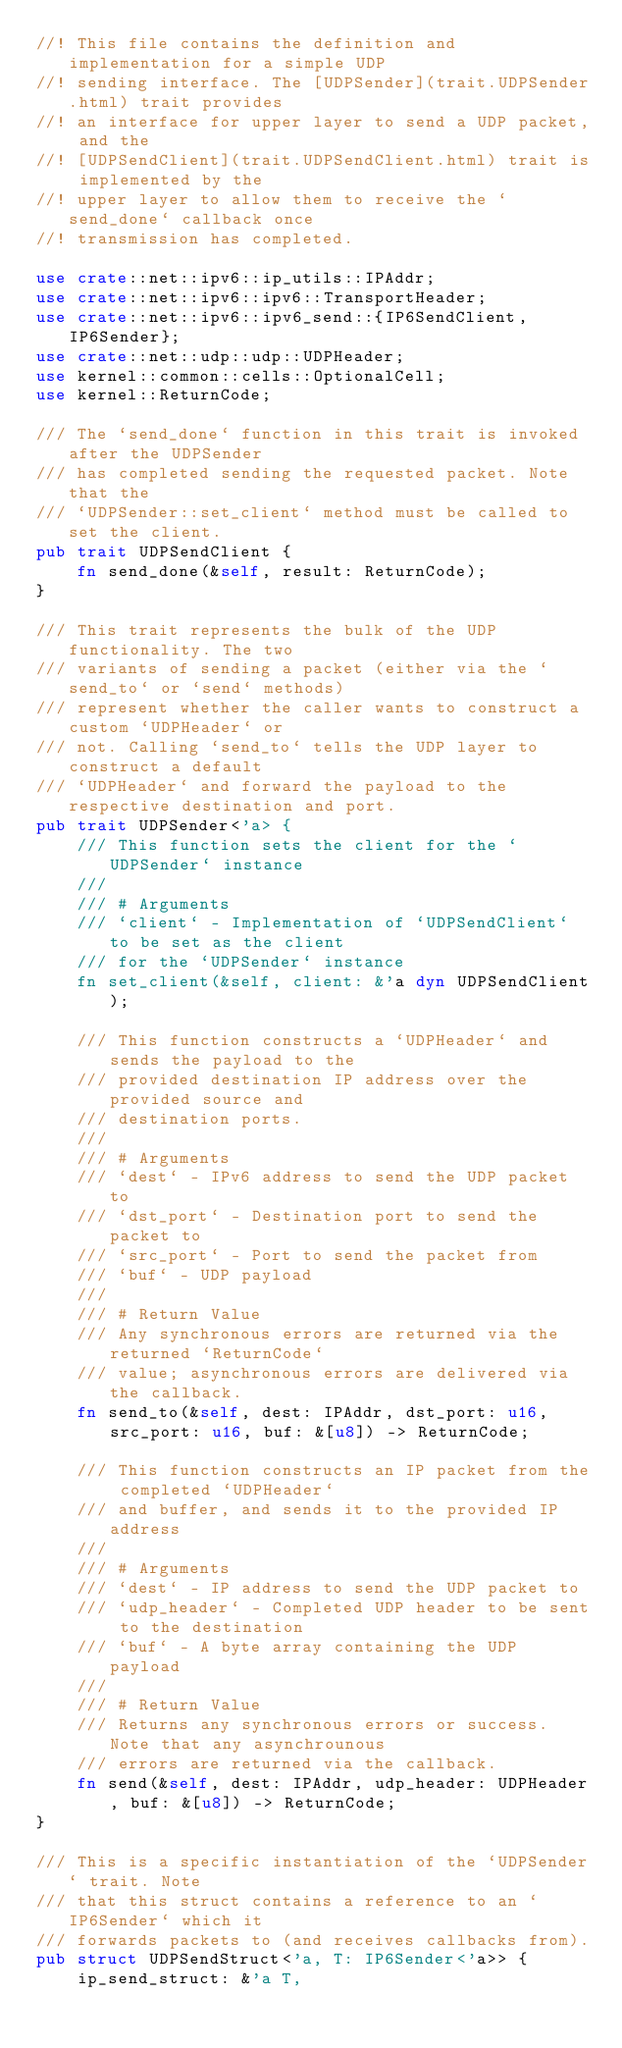Convert code to text. <code><loc_0><loc_0><loc_500><loc_500><_Rust_>//! This file contains the definition and implementation for a simple UDP
//! sending interface. The [UDPSender](trait.UDPSender.html) trait provides
//! an interface for upper layer to send a UDP packet, and the
//! [UDPSendClient](trait.UDPSendClient.html) trait is implemented by the
//! upper layer to allow them to receive the `send_done` callback once
//! transmission has completed.

use crate::net::ipv6::ip_utils::IPAddr;
use crate::net::ipv6::ipv6::TransportHeader;
use crate::net::ipv6::ipv6_send::{IP6SendClient, IP6Sender};
use crate::net::udp::udp::UDPHeader;
use kernel::common::cells::OptionalCell;
use kernel::ReturnCode;

/// The `send_done` function in this trait is invoked after the UDPSender
/// has completed sending the requested packet. Note that the
/// `UDPSender::set_client` method must be called to set the client.
pub trait UDPSendClient {
    fn send_done(&self, result: ReturnCode);
}

/// This trait represents the bulk of the UDP functionality. The two
/// variants of sending a packet (either via the `send_to` or `send` methods)
/// represent whether the caller wants to construct a custom `UDPHeader` or
/// not. Calling `send_to` tells the UDP layer to construct a default
/// `UDPHeader` and forward the payload to the respective destination and port.
pub trait UDPSender<'a> {
    /// This function sets the client for the `UDPSender` instance
    ///
    /// # Arguments
    /// `client` - Implementation of `UDPSendClient` to be set as the client
    /// for the `UDPSender` instance
    fn set_client(&self, client: &'a dyn UDPSendClient);

    /// This function constructs a `UDPHeader` and sends the payload to the
    /// provided destination IP address over the provided source and
    /// destination ports.
    ///
    /// # Arguments
    /// `dest` - IPv6 address to send the UDP packet to
    /// `dst_port` - Destination port to send the packet to
    /// `src_port` - Port to send the packet from
    /// `buf` - UDP payload
    ///
    /// # Return Value
    /// Any synchronous errors are returned via the returned `ReturnCode`
    /// value; asynchronous errors are delivered via the callback.
    fn send_to(&self, dest: IPAddr, dst_port: u16, src_port: u16, buf: &[u8]) -> ReturnCode;

    /// This function constructs an IP packet from the completed `UDPHeader`
    /// and buffer, and sends it to the provided IP address
    ///
    /// # Arguments
    /// `dest` - IP address to send the UDP packet to
    /// `udp_header` - Completed UDP header to be sent to the destination
    /// `buf` - A byte array containing the UDP payload
    ///
    /// # Return Value
    /// Returns any synchronous errors or success. Note that any asynchrounous
    /// errors are returned via the callback.
    fn send(&self, dest: IPAddr, udp_header: UDPHeader, buf: &[u8]) -> ReturnCode;
}

/// This is a specific instantiation of the `UDPSender` trait. Note
/// that this struct contains a reference to an `IP6Sender` which it
/// forwards packets to (and receives callbacks from).
pub struct UDPSendStruct<'a, T: IP6Sender<'a>> {
    ip_send_struct: &'a T,</code> 